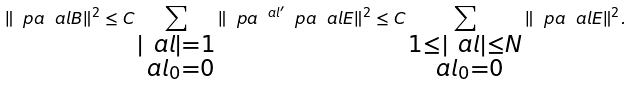<formula> <loc_0><loc_0><loc_500><loc_500>\| \ p a ^ { \ } a l B \| ^ { 2 } \leq C \sum _ { \substack { | \ a l | = 1 \\ \ a l _ { 0 } = 0 } } \| \ p a ^ { \ a l ^ { \prime } } \ p a ^ { \ } a l E \| ^ { 2 } \leq C \sum _ { \substack { 1 \leq | \ a l | \leq N \\ \ a l _ { 0 } = 0 } } \| \ p a ^ { \ } a l E \| ^ { 2 } .</formula> 